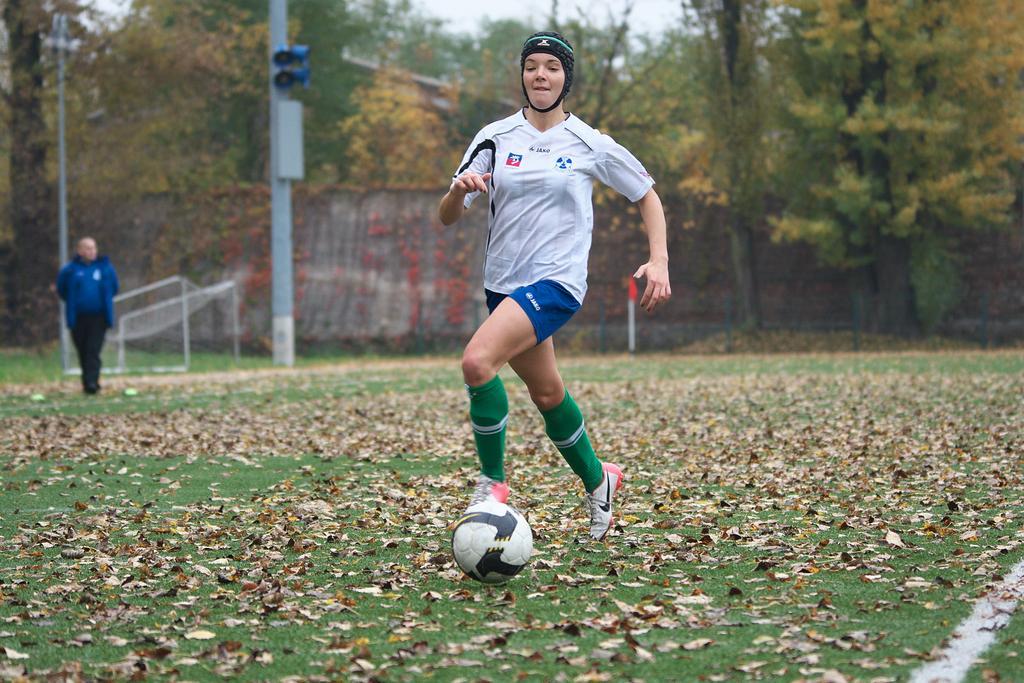In one or two sentences, can you explain what this image depicts? In this image, we can see a few people. Among them, we can see a person wearing T-shirt and shorts. We can see the ground and some dried leaves. There are a few trees, poles. We can see the net and the sky. We can also see a ball. 